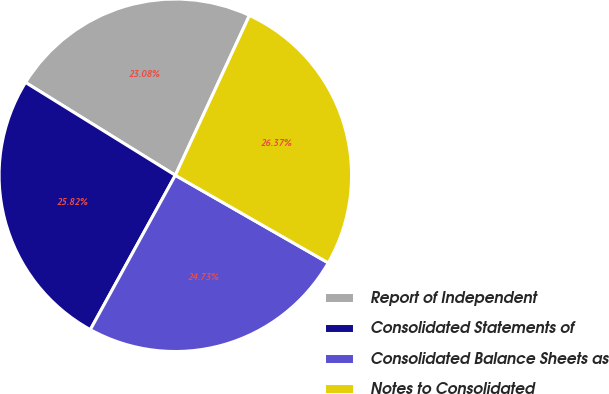<chart> <loc_0><loc_0><loc_500><loc_500><pie_chart><fcel>Report of Independent<fcel>Consolidated Statements of<fcel>Consolidated Balance Sheets as<fcel>Notes to Consolidated<nl><fcel>23.08%<fcel>25.82%<fcel>24.73%<fcel>26.37%<nl></chart> 